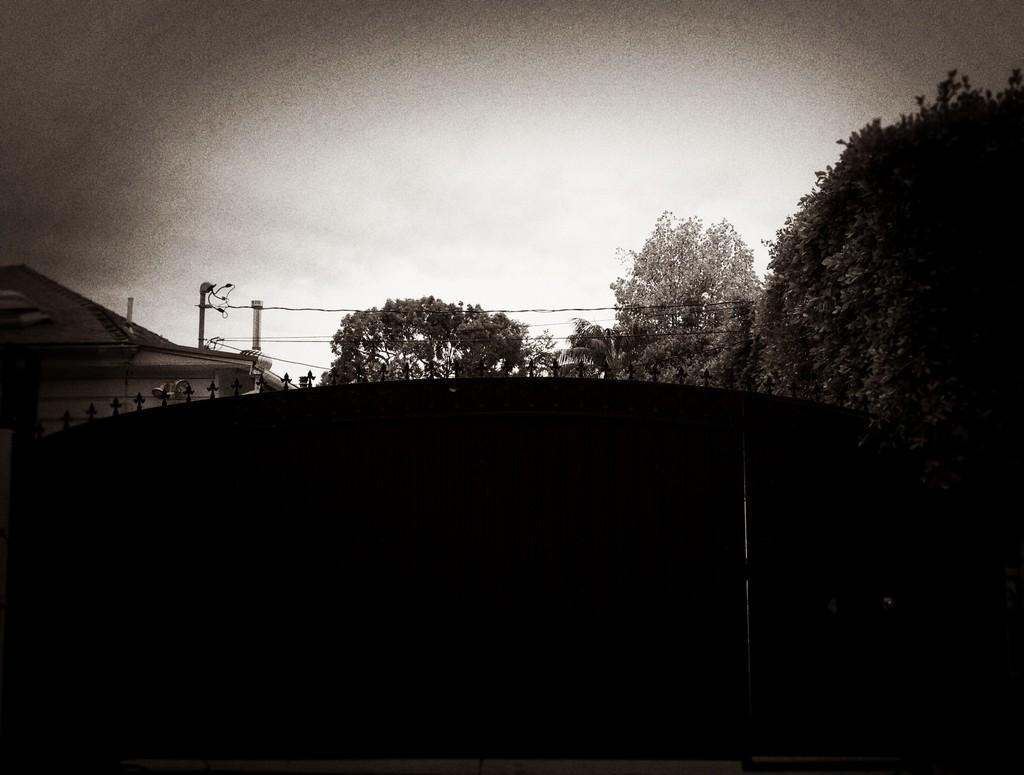How would you summarize this image in a sentence or two? In this picture we can see a building, trees, wires, poles and in the background we can see the sky. 